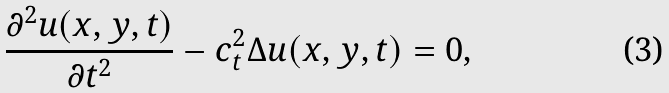<formula> <loc_0><loc_0><loc_500><loc_500>\frac { \partial ^ { 2 } u ( x , y , t ) } { \partial t ^ { 2 } } - c _ { t } ^ { 2 } \Delta u ( x , y , t ) = 0 ,</formula> 